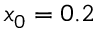<formula> <loc_0><loc_0><loc_500><loc_500>x _ { 0 } = 0 . 2</formula> 